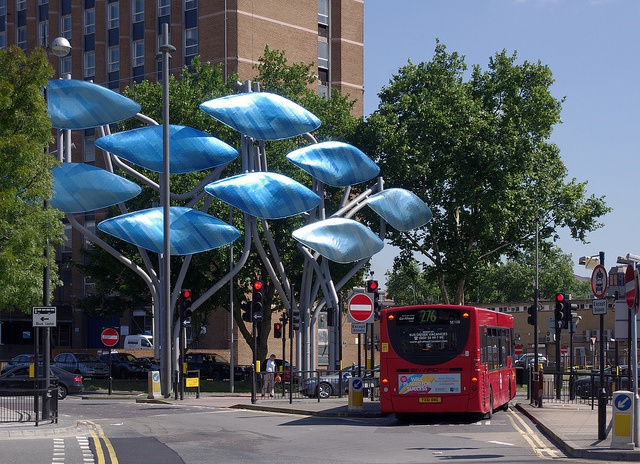Describe the objects in this image and their specific colors. I can see bus in navy, black, maroon, gray, and brown tones, car in navy, black, gray, and darkgray tones, car in navy, black, gray, and darkgray tones, car in navy, black, darkblue, and gray tones, and car in navy, black, and gray tones in this image. 